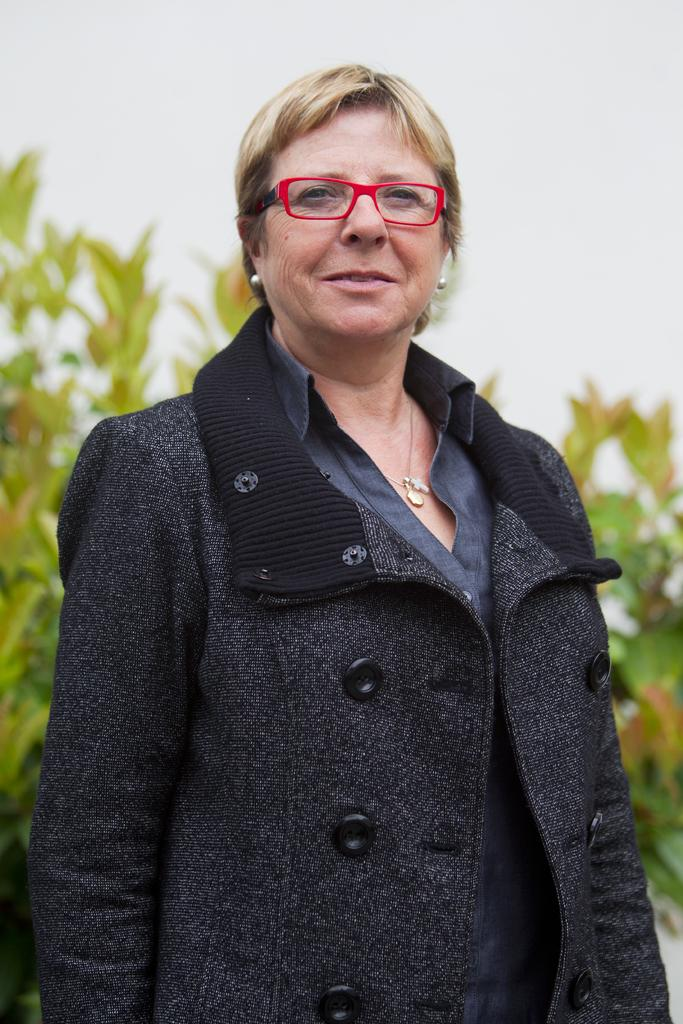Who is the main subject in the image? There is a woman in the image. What is the woman wearing? The woman is wearing glasses. What is the woman's posture in the image? The woman is standing. What can be seen in the background of the image? There are plants and the sky visible in the background of the image. What type of brass instrument is the woman playing in the image? There is no brass instrument present in the image; the woman is simply standing and wearing glasses. 